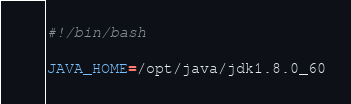<code> <loc_0><loc_0><loc_500><loc_500><_Bash_>#!/bin/bash

JAVA_HOME=/opt/java/jdk1.8.0_60</code> 